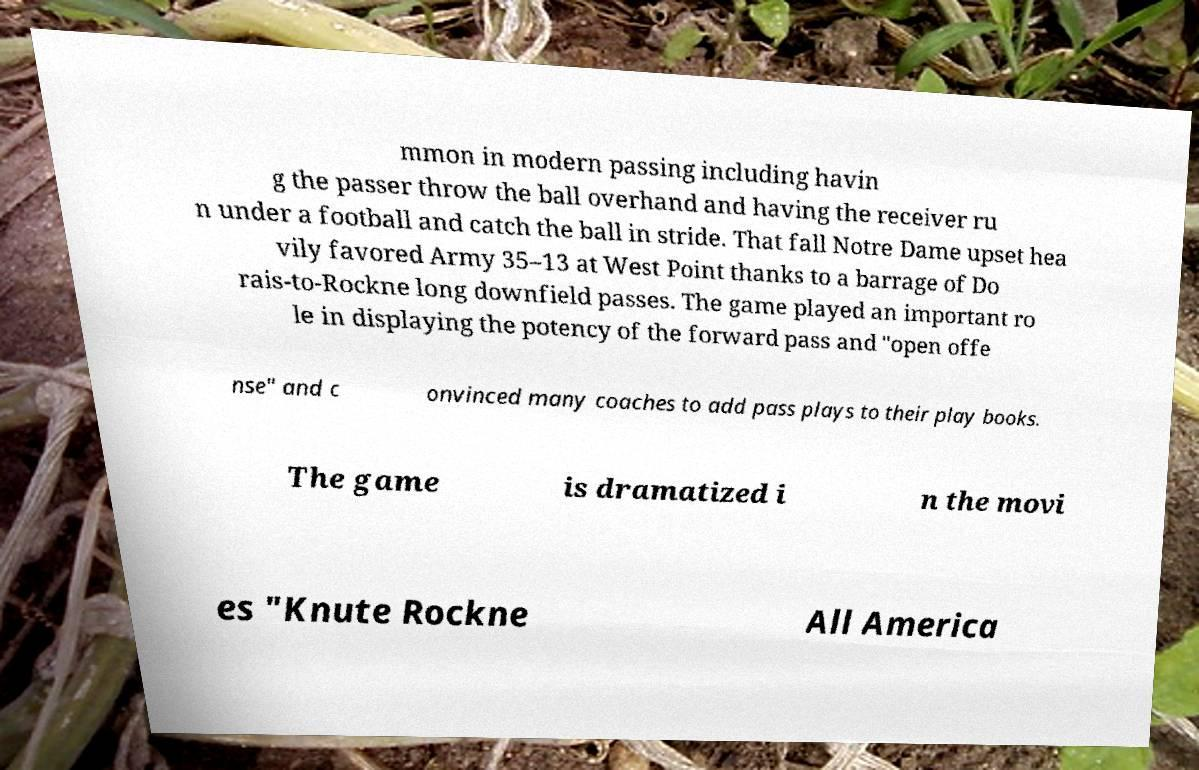Can you accurately transcribe the text from the provided image for me? mmon in modern passing including havin g the passer throw the ball overhand and having the receiver ru n under a football and catch the ball in stride. That fall Notre Dame upset hea vily favored Army 35–13 at West Point thanks to a barrage of Do rais-to-Rockne long downfield passes. The game played an important ro le in displaying the potency of the forward pass and "open offe nse" and c onvinced many coaches to add pass plays to their play books. The game is dramatized i n the movi es "Knute Rockne All America 